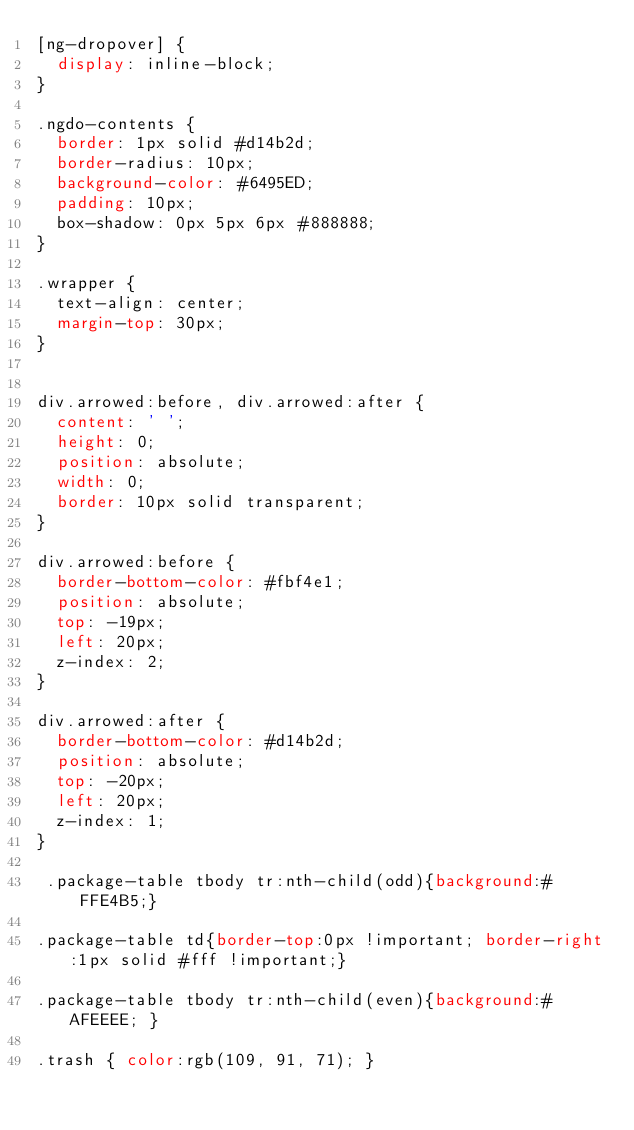<code> <loc_0><loc_0><loc_500><loc_500><_CSS_>[ng-dropover] {
  display: inline-block;
}

.ngdo-contents {
  border: 1px solid #d14b2d;
  border-radius: 10px;
  background-color: #6495ED;
  padding: 10px;
  box-shadow: 0px 5px 6px #888888;
}

.wrapper {
  text-align: center;
  margin-top: 30px;
}


div.arrowed:before, div.arrowed:after {
	content: ' ';
	height: 0;
	position: absolute;
	width: 0;
	border: 10px solid transparent;
}

div.arrowed:before {
	border-bottom-color: #fbf4e1;
	position: absolute;
	top: -19px;
	left: 20px;
	z-index: 2;
}

div.arrowed:after {
	border-bottom-color: #d14b2d;
	position: absolute;
	top: -20px;
	left: 20px;
	z-index: 1;
}

 .package-table tbody tr:nth-child(odd){background:#FFE4B5;}

.package-table td{border-top:0px !important; border-right:1px solid #fff !important;}

.package-table tbody tr:nth-child(even){background:#AFEEEE; }

.trash { color:rgb(109, 91, 71); }</code> 